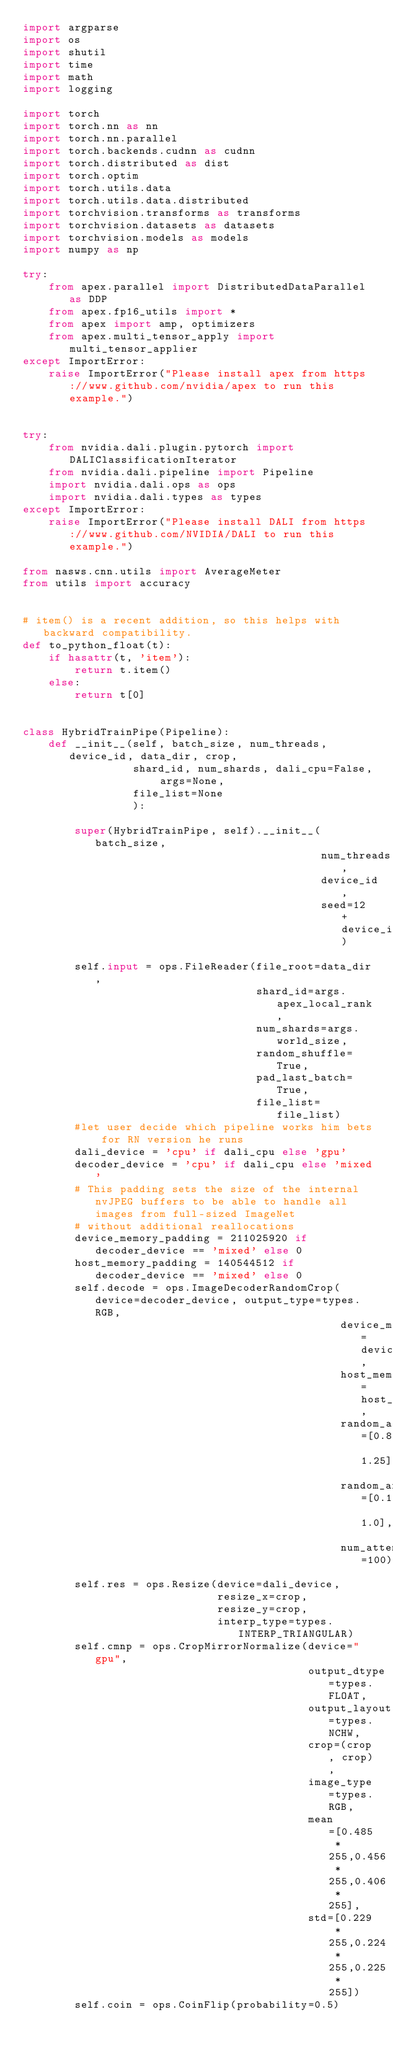Convert code to text. <code><loc_0><loc_0><loc_500><loc_500><_Python_>import argparse
import os
import shutil
import time
import math
import logging

import torch
import torch.nn as nn
import torch.nn.parallel
import torch.backends.cudnn as cudnn
import torch.distributed as dist
import torch.optim
import torch.utils.data
import torch.utils.data.distributed
import torchvision.transforms as transforms
import torchvision.datasets as datasets
import torchvision.models as models
import numpy as np

try:
    from apex.parallel import DistributedDataParallel as DDP
    from apex.fp16_utils import *
    from apex import amp, optimizers
    from apex.multi_tensor_apply import multi_tensor_applier
except ImportError:
    raise ImportError("Please install apex from https://www.github.com/nvidia/apex to run this example.")


try:
    from nvidia.dali.plugin.pytorch import DALIClassificationIterator
    from nvidia.dali.pipeline import Pipeline
    import nvidia.dali.ops as ops
    import nvidia.dali.types as types
except ImportError:
    raise ImportError("Please install DALI from https://www.github.com/NVIDIA/DALI to run this example.")

from nasws.cnn.utils import AverageMeter
from utils import accuracy


# item() is a recent addition, so this helps with backward compatibility.
def to_python_float(t):
    if hasattr(t, 'item'):
        return t.item()
    else:
        return t[0]


class HybridTrainPipe(Pipeline):
    def __init__(self, batch_size, num_threads, device_id, data_dir, crop,
                 shard_id, num_shards, dali_cpu=False, args=None,
                 file_list=None
                 ):
        
        super(HybridTrainPipe, self).__init__(batch_size,
                                              num_threads,
                                              device_id,
                                              seed=12 + device_id)
        
        self.input = ops.FileReader(file_root=data_dir,
                                    shard_id=args.apex_local_rank,
                                    num_shards=args.world_size,
                                    random_shuffle=True,
                                    pad_last_batch=True,
                                    file_list=file_list)
        #let user decide which pipeline works him bets for RN version he runs
        dali_device = 'cpu' if dali_cpu else 'gpu'
        decoder_device = 'cpu' if dali_cpu else 'mixed'
        # This padding sets the size of the internal nvJPEG buffers to be able to handle all images from full-sized ImageNet
        # without additional reallocations
        device_memory_padding = 211025920 if decoder_device == 'mixed' else 0
        host_memory_padding = 140544512 if decoder_device == 'mixed' else 0
        self.decode = ops.ImageDecoderRandomCrop(device=decoder_device, output_type=types.RGB,
                                                 device_memory_padding=device_memory_padding,
                                                 host_memory_padding=host_memory_padding,
                                                 random_aspect_ratio=[0.8, 1.25],
                                                 random_area=[0.1, 1.0],
                                                 num_attempts=100)
        self.res = ops.Resize(device=dali_device,
                              resize_x=crop,
                              resize_y=crop,
                              interp_type=types.INTERP_TRIANGULAR)
        self.cmnp = ops.CropMirrorNormalize(device="gpu",
                                            output_dtype=types.FLOAT,
                                            output_layout=types.NCHW,
                                            crop=(crop, crop),
                                            image_type=types.RGB,
                                            mean=[0.485 * 255,0.456 * 255,0.406 * 255],
                                            std=[0.229 * 255,0.224 * 255,0.225 * 255])
        self.coin = ops.CoinFlip(probability=0.5)</code> 